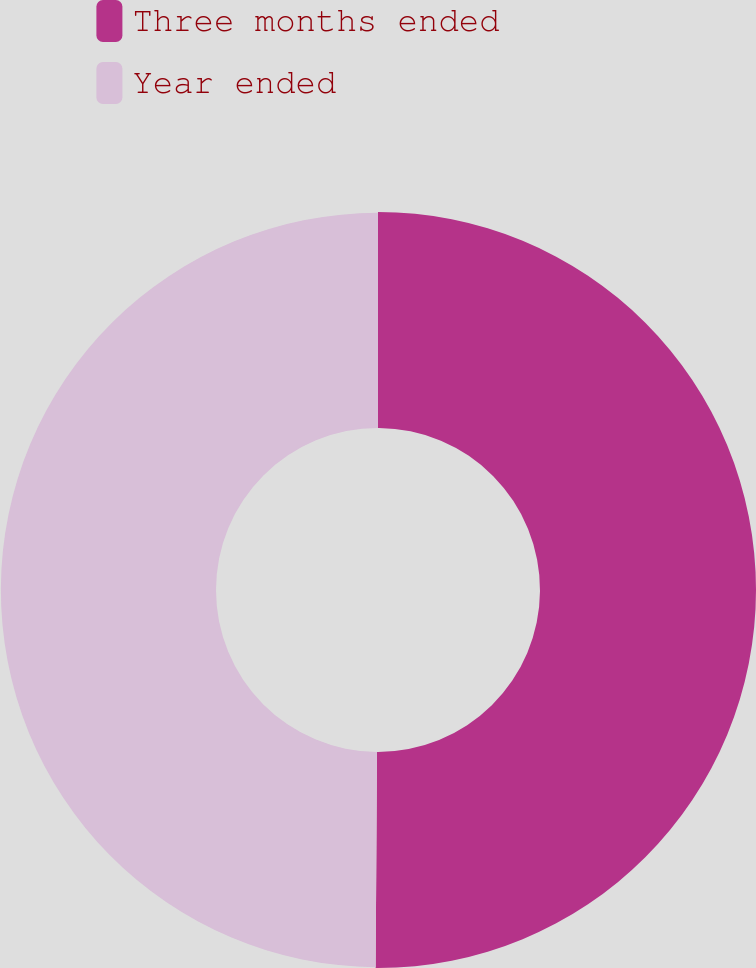Convert chart. <chart><loc_0><loc_0><loc_500><loc_500><pie_chart><fcel>Three months ended<fcel>Year ended<nl><fcel>50.1%<fcel>49.9%<nl></chart> 